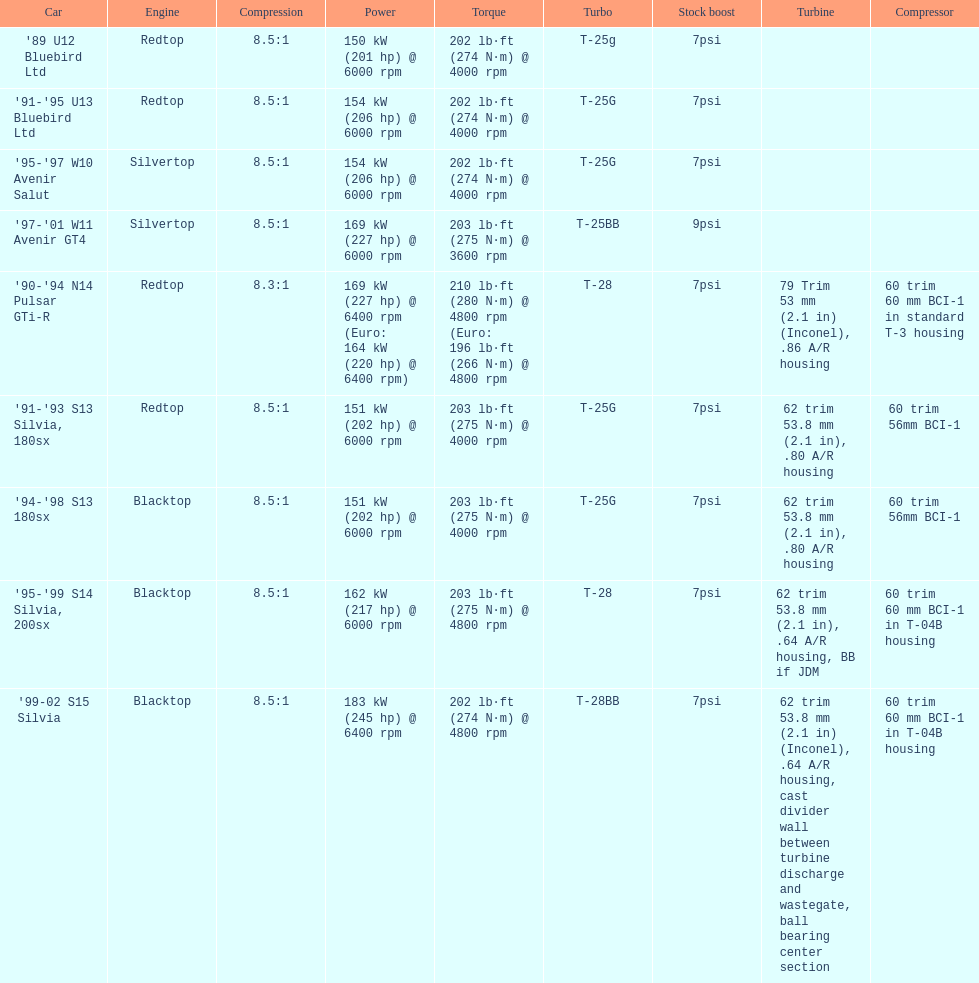Which automobile has a standard boost of over 7psi? '97-'01 W11 Avenir GT4. 